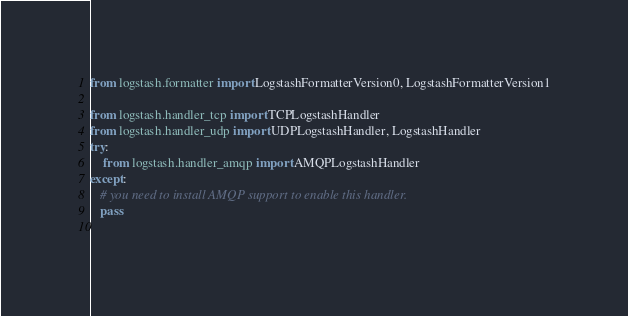Convert code to text. <code><loc_0><loc_0><loc_500><loc_500><_Python_>
from logstash.formatter import LogstashFormatterVersion0, LogstashFormatterVersion1

from logstash.handler_tcp import TCPLogstashHandler
from logstash.handler_udp import UDPLogstashHandler, LogstashHandler
try:
    from logstash.handler_amqp import AMQPLogstashHandler
except:
   # you need to install AMQP support to enable this handler.
   pass
 


</code> 